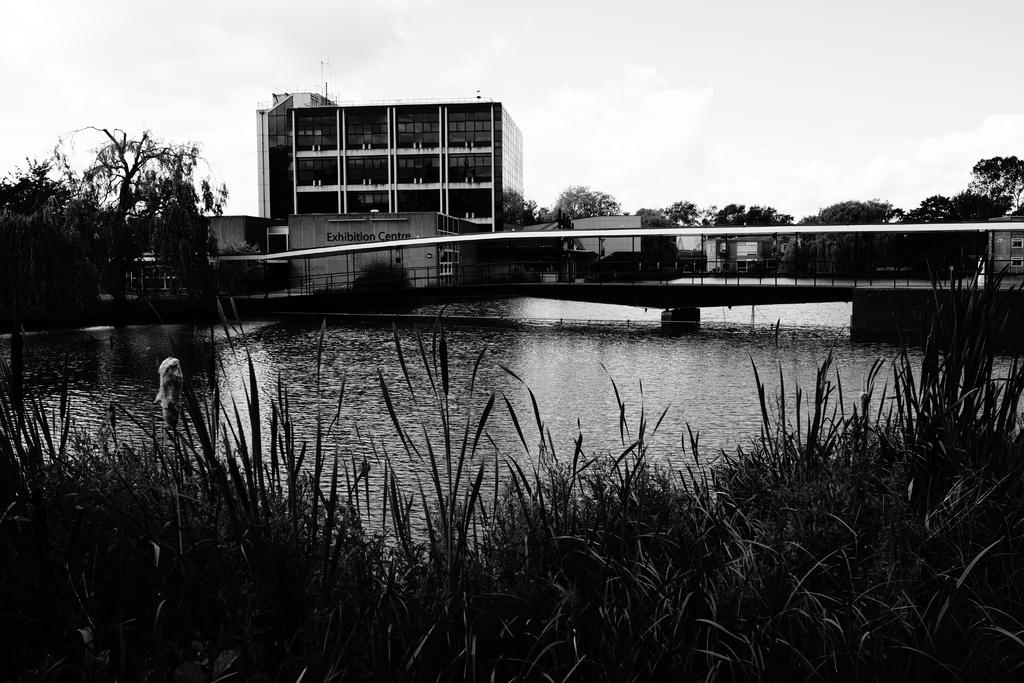What type of natural environment is visible in the image? There is grass and water visible in the image. What man-made structure can be seen in the image? There is a bridge in the image. What can be seen in the background of the image? There are buildings, trees, and the sky visible in the background of the image. What type of pollution can be seen in the image? There is no pollution visible in the image. Can you tell me how many basketballs are present in the image? There are no basketballs present in the image. 